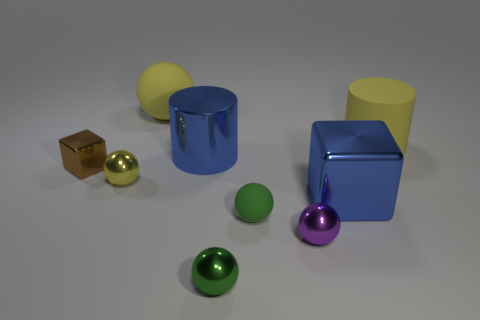Do the blue metallic thing in front of the small brown shiny block and the yellow metallic thing have the same shape?
Ensure brevity in your answer.  No. There is a yellow object that is right of the purple metallic thing; what is its material?
Offer a very short reply. Rubber. There is a yellow matte object that is left of the big yellow rubber object in front of the big matte ball; what shape is it?
Your response must be concise. Sphere. Do the brown object and the large yellow matte object that is left of the yellow cylinder have the same shape?
Offer a very short reply. No. How many small green spheres are in front of the large rubber thing right of the purple shiny object?
Provide a short and direct response. 2. What is the material of the big thing that is the same shape as the small brown thing?
Offer a terse response. Metal. How many brown objects are matte cylinders or big rubber balls?
Give a very brief answer. 0. Is there anything else that is the same color as the shiny cylinder?
Provide a succinct answer. Yes. What color is the large metallic object behind the small metal sphere behind the tiny purple sphere?
Offer a terse response. Blue. Is the number of yellow balls in front of the tiny purple metal object less than the number of blue shiny objects that are behind the yellow metallic thing?
Ensure brevity in your answer.  Yes. 